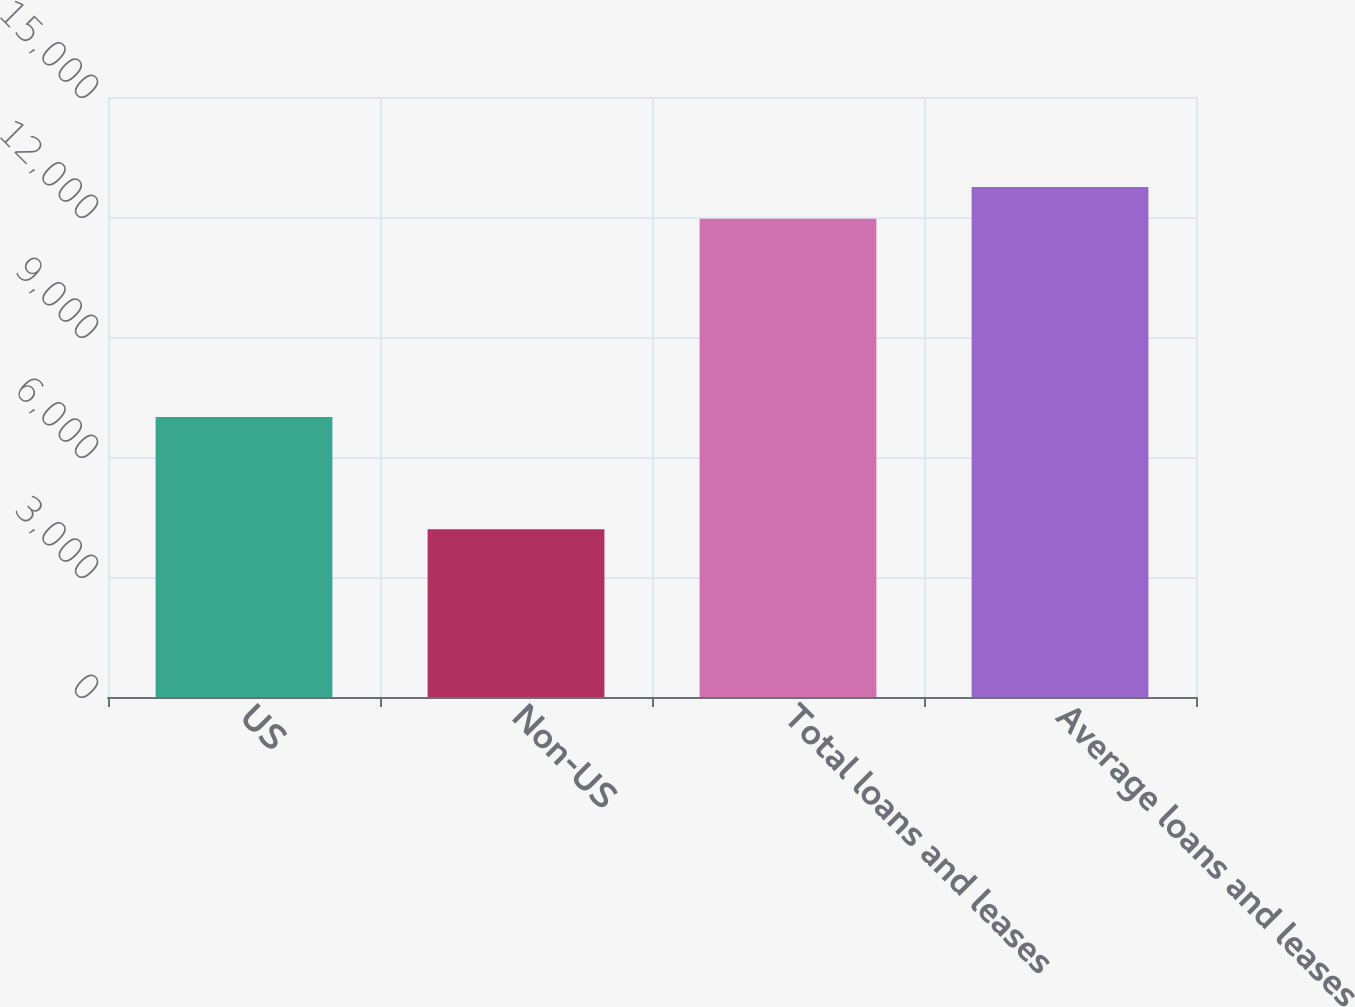Convert chart. <chart><loc_0><loc_0><loc_500><loc_500><bar_chart><fcel>US<fcel>Non-US<fcel>Total loans and leases<fcel>Average loans and leases<nl><fcel>7001<fcel>4192<fcel>11957<fcel>12747.2<nl></chart> 